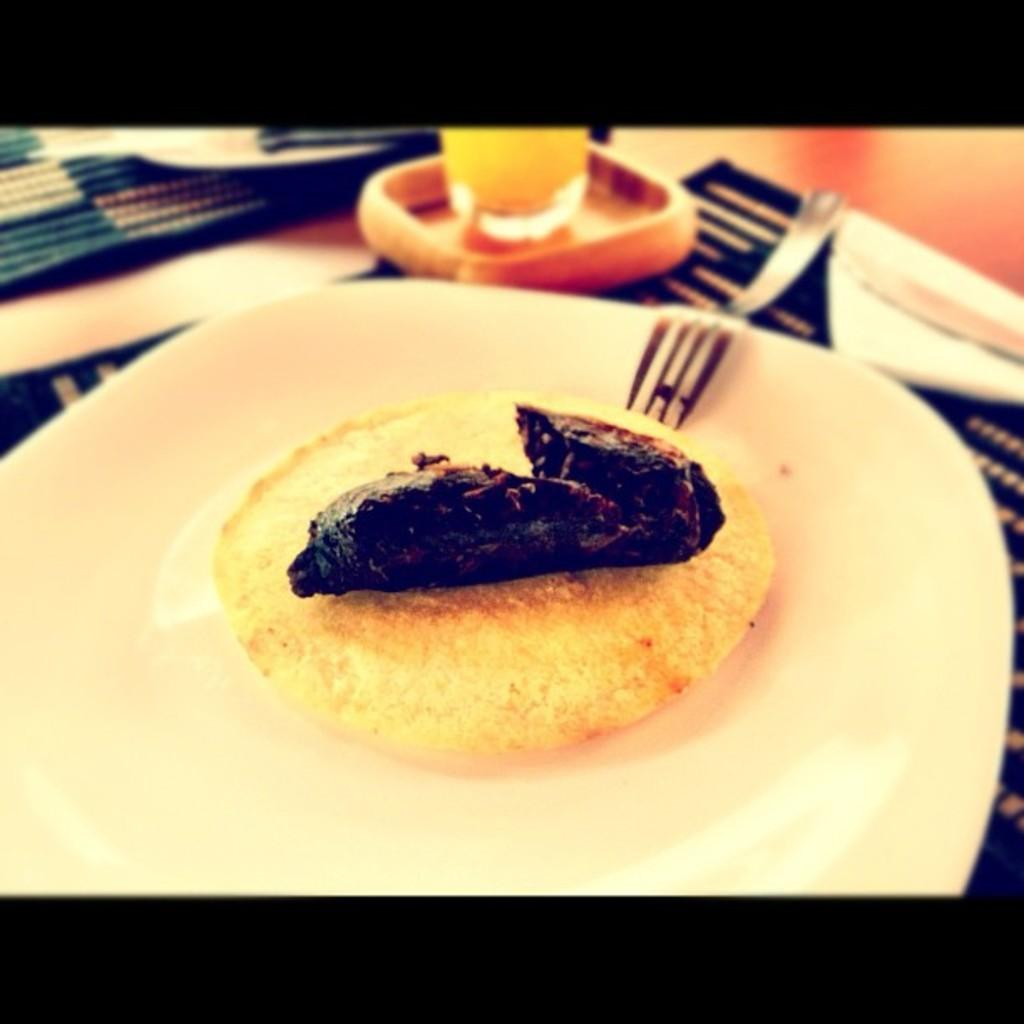What is the food item in the image? The specific food item is not mentioned, but there is a food item in the image. What utensil is present in the image? There is a fork in the image. Where is the fork placed? The fork is placed on a plate. What is the drink-related item in the image? There is a glass of drink in the image. Where is the glass of drink placed? The glass of drink is placed on a table. Reasoning: Let's think step by following the guidelines to produce the conversation. We start by mentioning the food item, but since its specific type is not given, we keep it general. Then, we describe the utensil and its placement, followed by the drink-related item and its location. Each question is designed to elicit a specific detail about the image that is known from the provided facts. Absurd Question/Answer: What type of ear is visible in the image? There is no ear present in the image. What type of approval is being sought in the image? There is no indication of approval or any related activity in the image. 